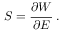<formula> <loc_0><loc_0><loc_500><loc_500>{ S } = { \cfrac { \partial W } { \partial { E } } } .</formula> 